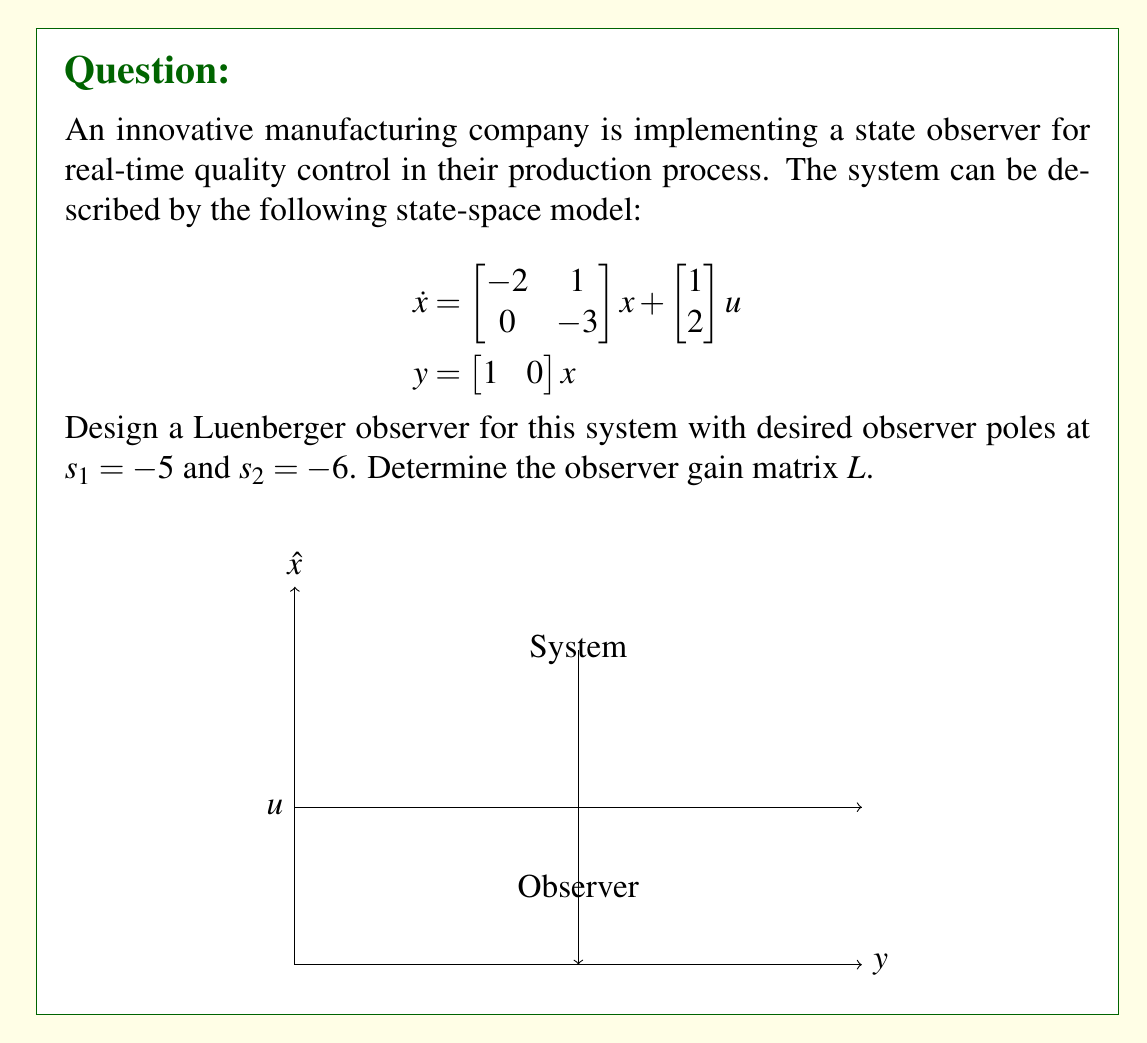Provide a solution to this math problem. To design a Luenberger observer, we need to follow these steps:

1) The observer dynamics are given by:
   $$\dot{\hat{x}} = A\hat{x} + Bu + L(y - C\hat{x})$$
   where $L$ is the observer gain matrix we need to determine.

2) The observer error dynamics are:
   $$\dot{e} = (A - LC)e$$
   where $e = x - \hat{x}$

3) We need to choose $L$ such that $(A - LC)$ has the desired eigenvalues $s_1 = -5$ and $s_2 = -6$.

4) The characteristic equation of $(A - LC)$ is:
   $$\det(sI - (A - LC)) = s^2 + (5+6)s + 5\cdot6 = s^2 + 11s + 30$$

5) Expanding $\det(sI - (A - LC))$:
   $$\begin{vmatrix}
   s+2-l_1 & -1 \\
   -l_2 & s+3
   \end{vmatrix} = s^2 + (5-l_1)s + (6-3l_1-l_2) = s^2 + 11s + 30$$

6) Comparing coefficients:
   $$5-l_1 = 11 \implies l_1 = -6$$
   $$6-3l_1-l_2 = 30 \implies -12-l_2 = 30 \implies l_2 = -42$$

7) Therefore, the observer gain matrix is:
   $$L = \begin{bmatrix} -6 \\ -42 \end{bmatrix}$$
Answer: $L = \begin{bmatrix} -6 \\ -42 \end{bmatrix}$ 